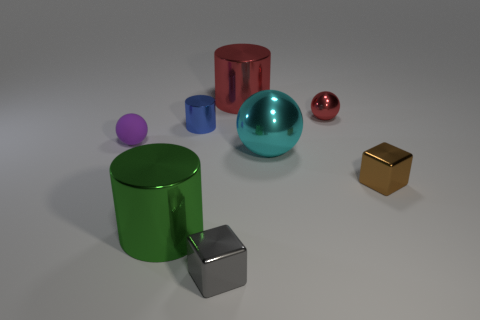There is a cylinder right of the tiny cylinder; does it have the same color as the tiny shiny sphere?
Make the answer very short. Yes. Are there any large metal cylinders of the same color as the tiny metal ball?
Make the answer very short. Yes. How many things are shiny things in front of the large green metal cylinder or tiny objects right of the tiny gray cube?
Give a very brief answer. 3. What is the color of the other metal cylinder that is the same size as the green shiny cylinder?
Provide a short and direct response. Red. Is the small red object made of the same material as the gray object?
Give a very brief answer. Yes. There is a small ball left of the large shiny cylinder behind the tiny matte thing; what is it made of?
Provide a short and direct response. Rubber. Is the number of small blue objects that are in front of the tiny brown cube greater than the number of brown cubes?
Offer a very short reply. No. What number of other things are there of the same size as the green shiny cylinder?
Your response must be concise. 2. Is the tiny matte object the same color as the tiny metallic ball?
Provide a succinct answer. No. There is a cube that is to the right of the big metal object behind the metal sphere on the right side of the large ball; what color is it?
Ensure brevity in your answer.  Brown. 